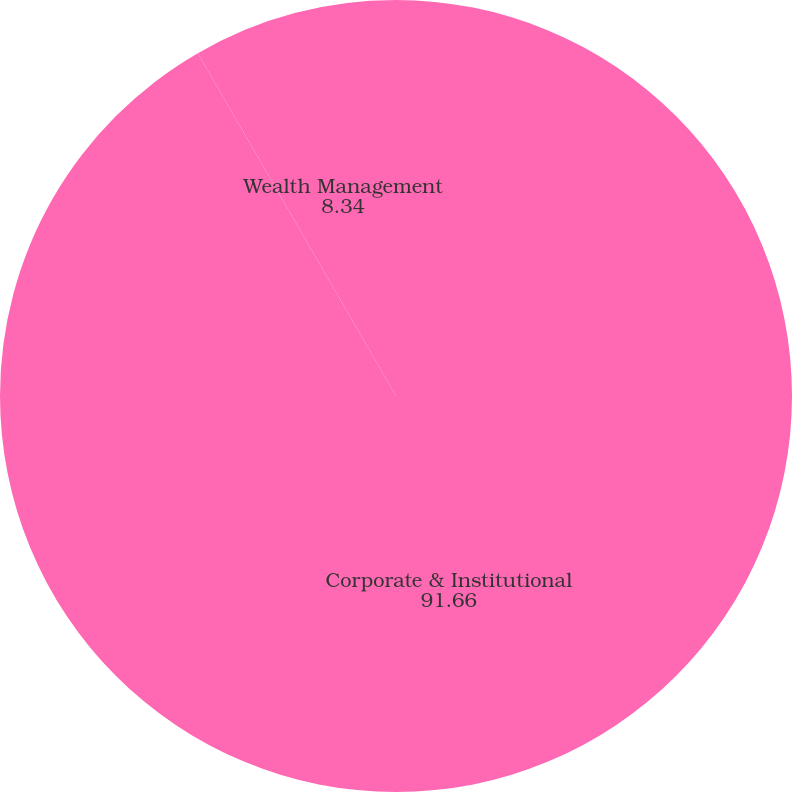<chart> <loc_0><loc_0><loc_500><loc_500><pie_chart><fcel>Corporate & Institutional<fcel>Wealth Management<nl><fcel>91.66%<fcel>8.34%<nl></chart> 